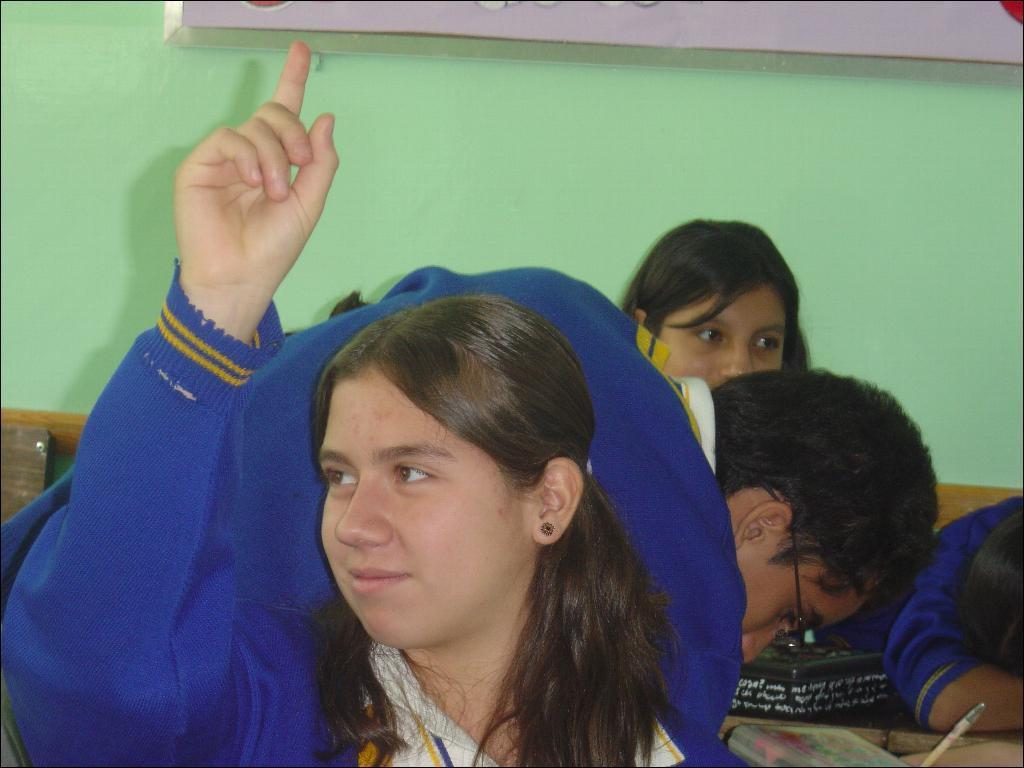Who is the main subject in the image? There is a girl in the image. What is the girl wearing? The girl is wearing clothes and ear studs. What is the girl's expression in the image? The girl is smiling. Are there any other people in the image? Yes, there are other children in the image. What are the other children wearing? The other children are wearing clothes. What else can be seen in the image? There are books visible in the image. What is the background of the image? There is a wall in the image. What type of paste is being used by the lawyer in the image? There is no lawyer or paste present in the image. 